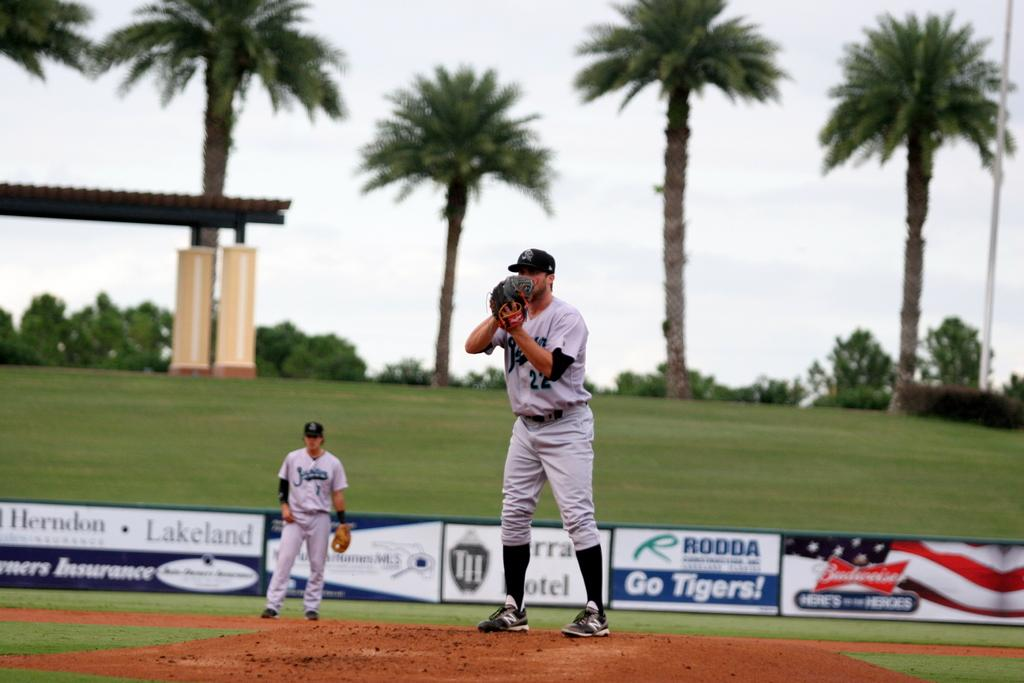<image>
Offer a succinct explanation of the picture presented. a baseball pitcher in lakeland Florida framed by palm trees beyond the advertisements 